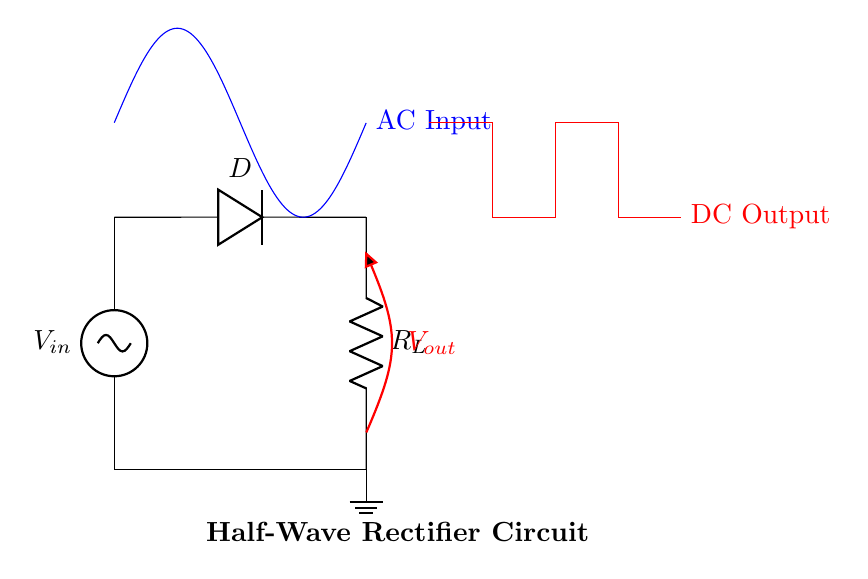What type of rectifier is shown in the circuit? The circuit diagram clearly depicts a half-wave rectifier, characterized by its use of a single diode which allows current to flow only during one half of the AC input waveform.
Answer: Half-wave What is the main function of the diode in this circuit? The diode's primary role in the half-wave rectifier circuit is to permit current flow in only one direction (forward bias) and block it during the opposite half cycle (reverse bias), thus converting AC to DC.
Answer: Convert AC to DC What is the symbol used for the load resistor? In the circuit, the load resistor is represented by the letter R with a subscript L, which is a common notation used to denote the load in electrical circuits.
Answer: R_L What is the shape of the output voltage waveform? The output voltage waveform of a half-wave rectifier typically takes the form of a series of positive pulses, reflecting the part of the AC input waveform that passes through the diode when it is forward-biased.
Answer: Pulses What happens to the output during the negative half cycle of the AC input? During the negative half cycle of the AC input, the diode becomes reverse-biased and prevents current from flowing, resulting in zero output voltage at that time.
Answer: Zero voltage What is the voltage across the AC input during its peak? The peak voltage is clearly indicated in the AC input waveform, which peaks at 5.5 volts, the highest amplitude of the input signal.
Answer: 5.5 volts How does the load resistor affect the overall circuit performance? The value of the load resistor significantly influences the output voltage and current: higher resistance results in lower current and voltage across the load, while lower resistance allows for higher current and potentially higher output voltage, but may also risk damaging the diode.
Answer: Affects voltage and current 